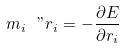<formula> <loc_0><loc_0><loc_500><loc_500>m _ { i } { \ " r } _ { i } = - \frac { \partial E } { \partial { r } _ { i } }</formula> 